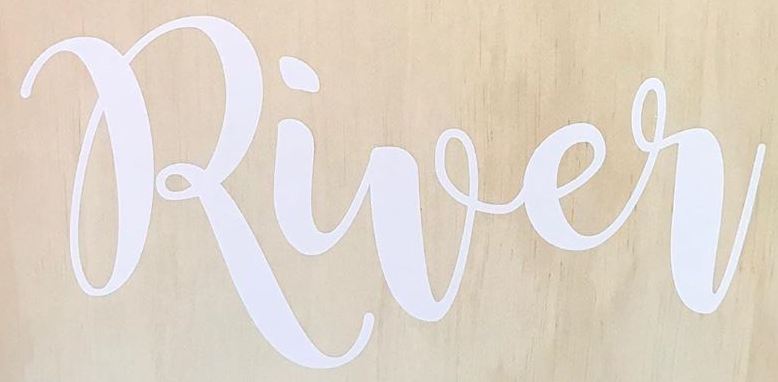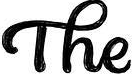Read the text content from these images in order, separated by a semicolon. River; The 